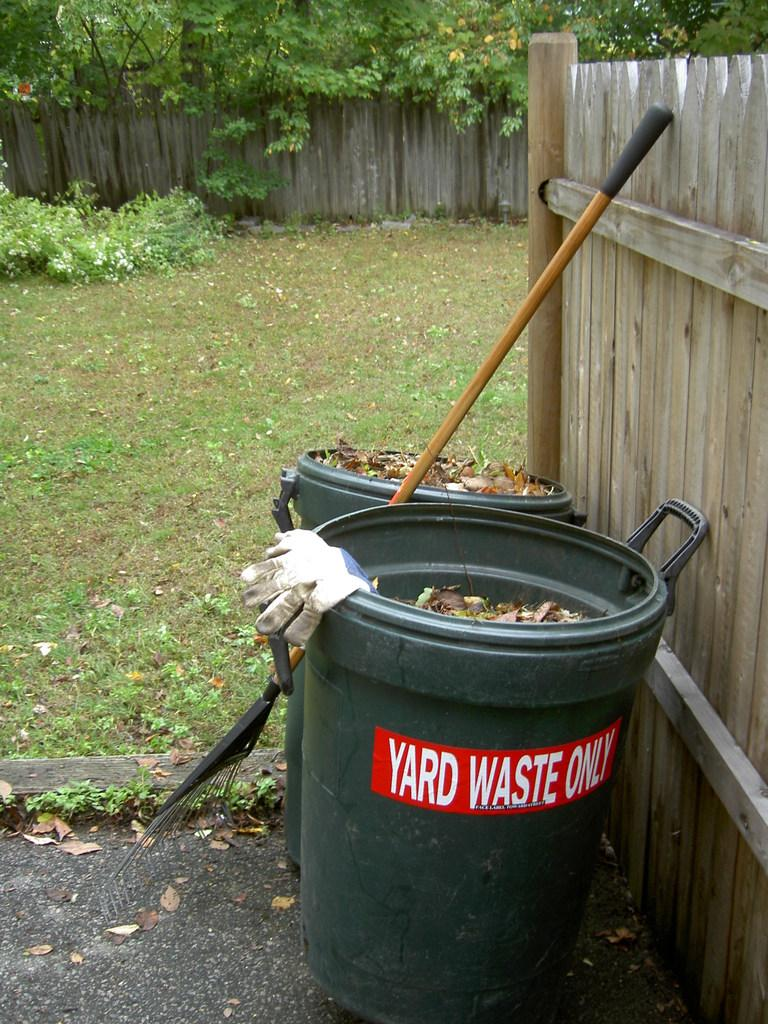<image>
Present a compact description of the photo's key features. a trash bin with a yard waste only sign on it 